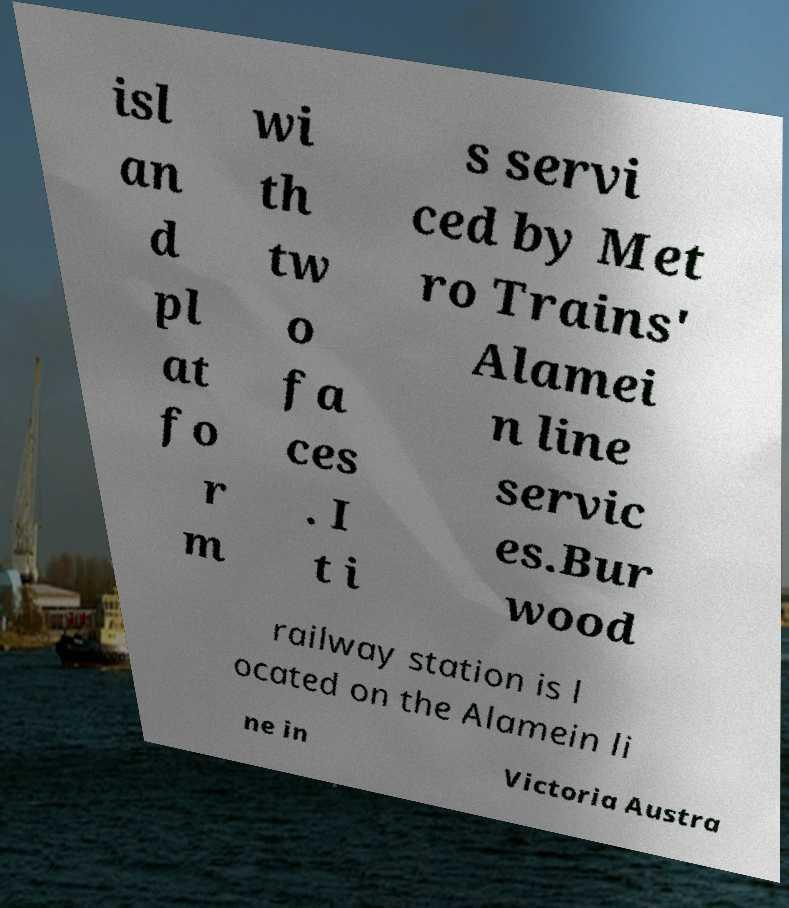What messages or text are displayed in this image? I need them in a readable, typed format. isl an d pl at fo r m wi th tw o fa ces . I t i s servi ced by Met ro Trains' Alamei n line servic es.Bur wood railway station is l ocated on the Alamein li ne in Victoria Austra 